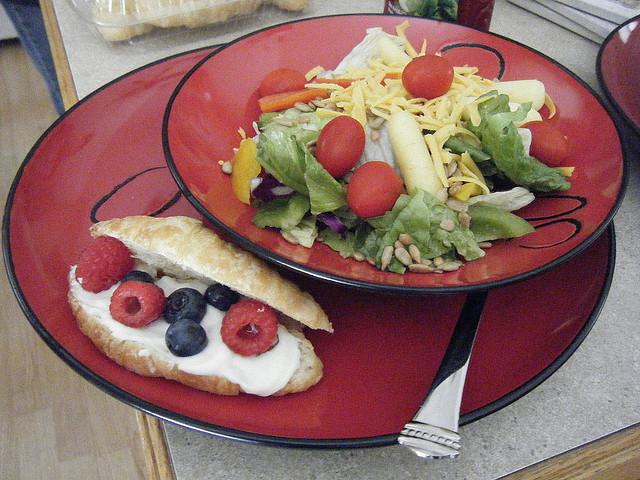What color is the plate?
Be succinct. Red. What is the color of the plates?
Answer briefly. Red. What kind of fruit is shown?
Keep it brief. Blueberries and raspberries. Is the food hot?
Quick response, please. No. Are the veggies whole?
Keep it brief. No. What is in the bowl?
Concise answer only. Salad. 